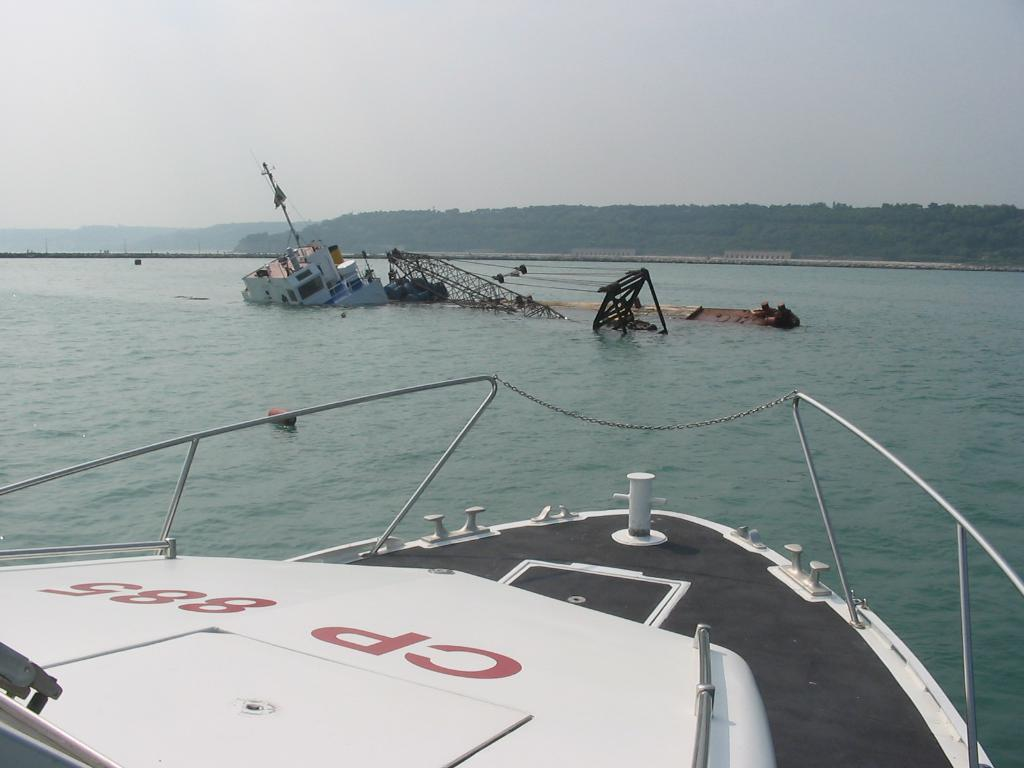What is the main subject in the foreground of the image? There is a ship in the foreground of the image. Can you describe the other ship in the image? There is another ship in the background of the image, and it is going into the water. What can be seen on the cliffs in the background of the image? There are trees on the cliffs in the background of the image. What is visible at the top of the image? The sky is visible at the top of the image. What type of system is being used to control the movement of the ship in the image? There is no information about a system controlling the movement of the ship in the image. Can you tell me which jewel is being worn by the captain of the ship in the image? There is no information about a captain or any jewelry in the image. 